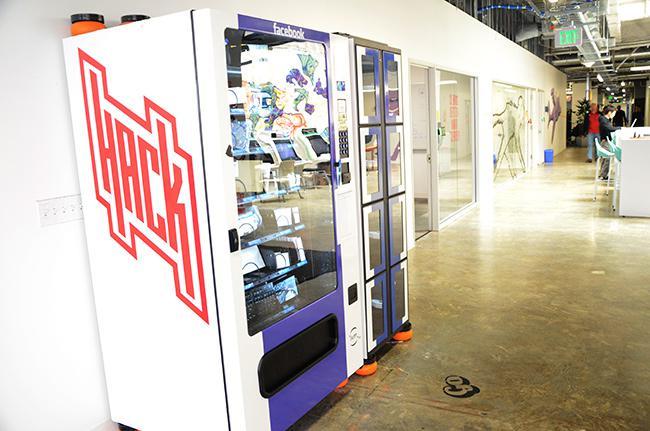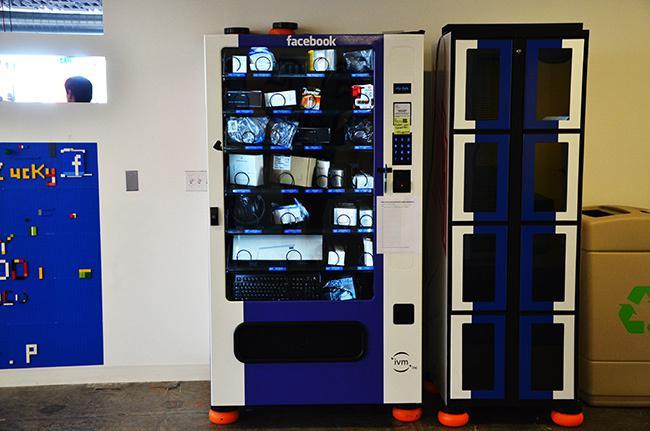The first image is the image on the left, the second image is the image on the right. Assess this claim about the two images: "There is a woman touching a vending machine.". Correct or not? Answer yes or no. No. The first image is the image on the left, the second image is the image on the right. For the images shown, is this caption "In each image, at least one person is at a vending machine." true? Answer yes or no. No. 